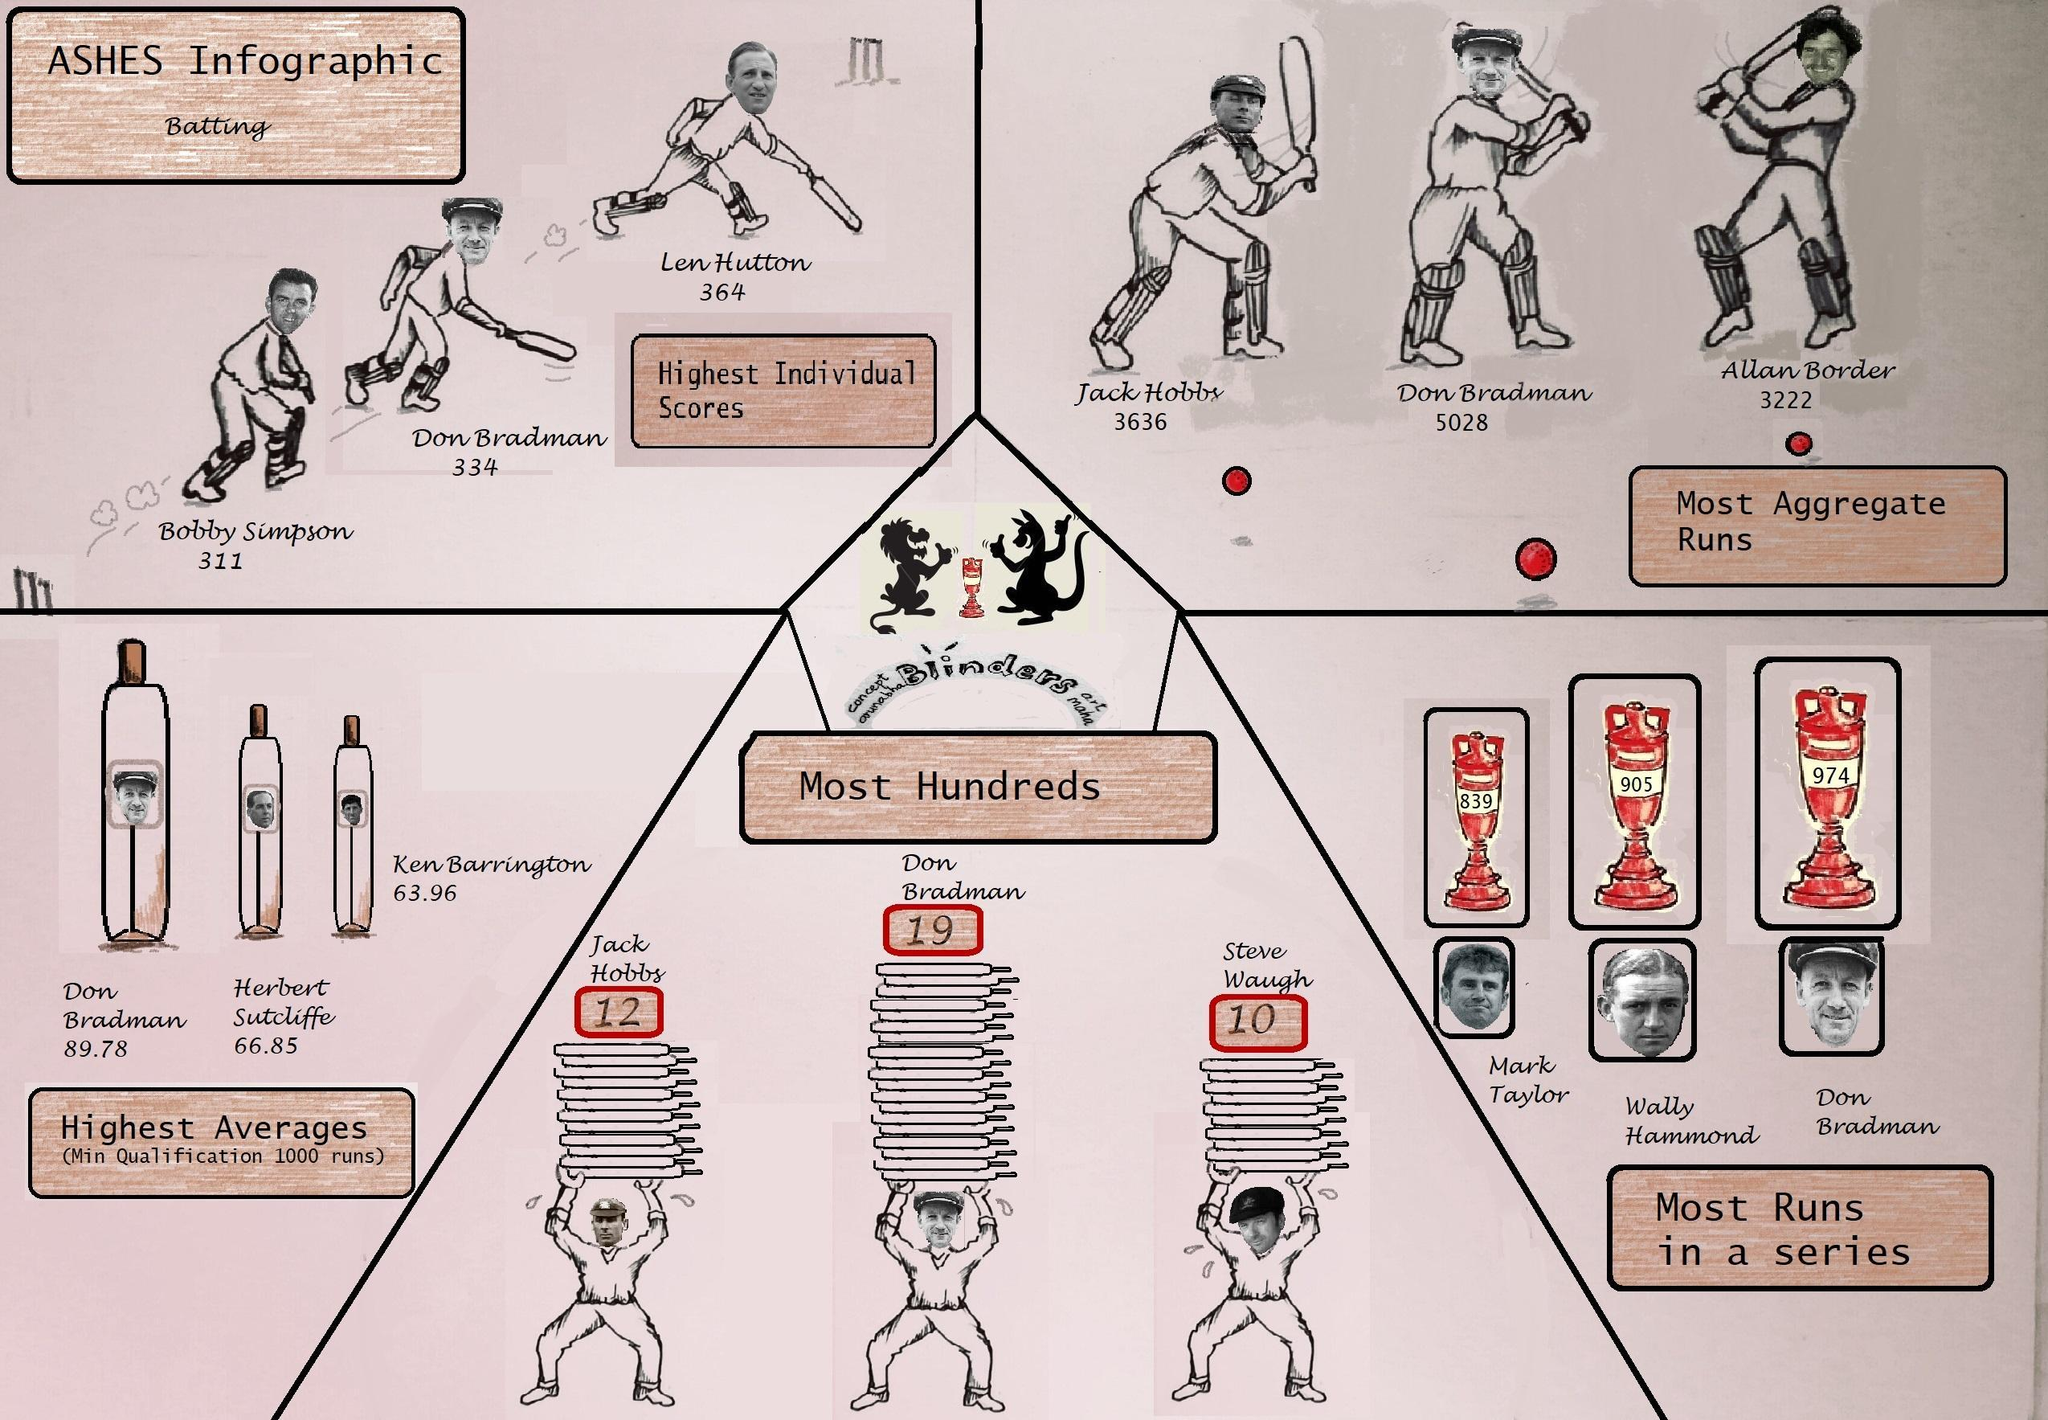Which is the second-highest individual score?
Answer the question with a short phrase. 334 What is the second most aggregate run? 3636 Who has the second-highest individual score? Don Bradman What is the average of Herbert Sutcliffe? 66.85 What is the number of hundreds scored by Jack Hobby? 12 Which is the second-highest average? 66.85 Who has the highest individual score? Len Hutton Who has the highest number of hundreds? Don Bradman 